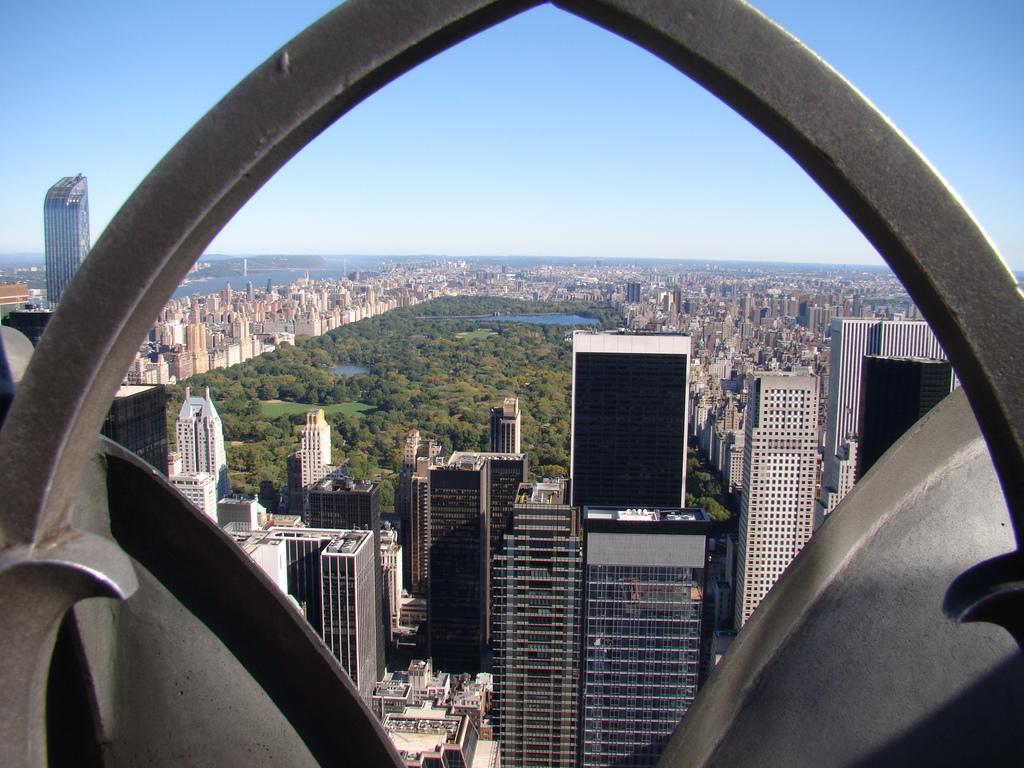Can you describe this image briefly? In this picture we can see an arch, buildings, trees, water and in the background we can see the sky. 